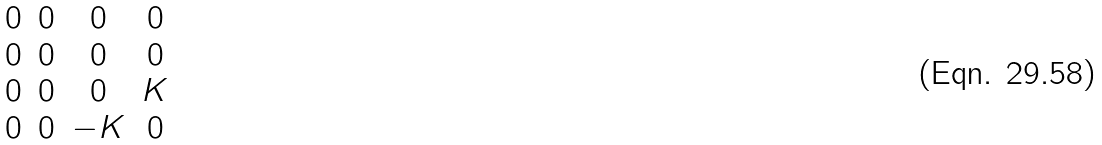Convert formula to latex. <formula><loc_0><loc_0><loc_500><loc_500>\begin{matrix} 0 & 0 & 0 & 0 \\ 0 & 0 & 0 & 0 \\ 0 & 0 & 0 & K \\ 0 & 0 & - K & 0 \end{matrix}</formula> 